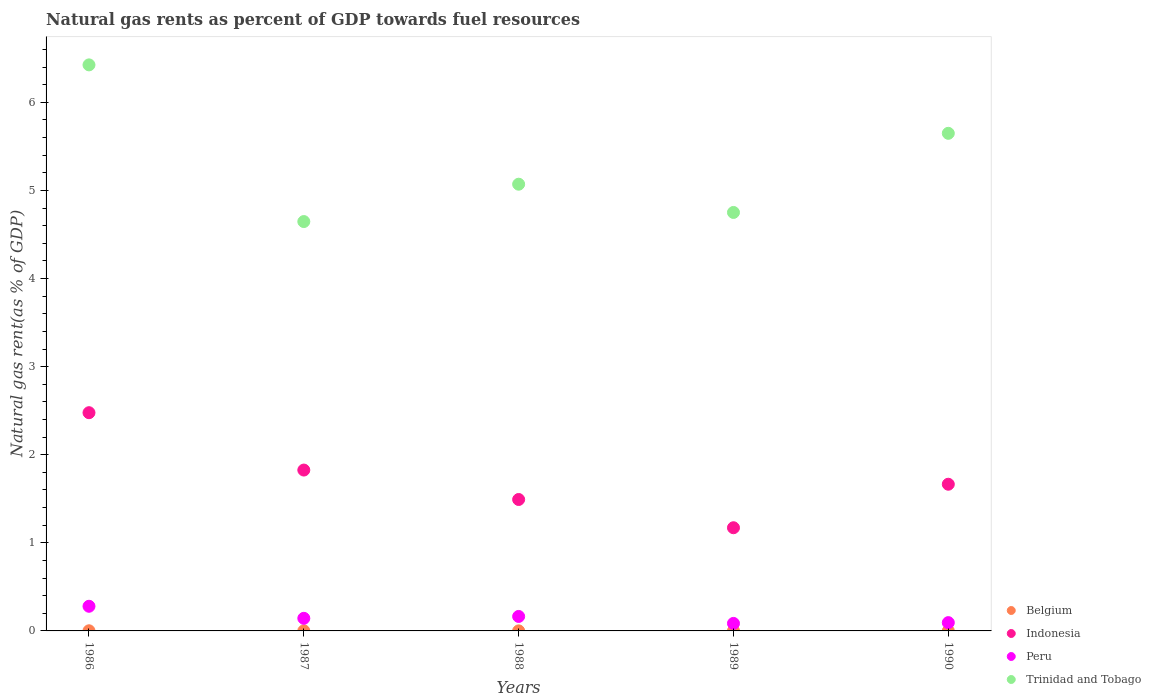What is the natural gas rent in Trinidad and Tobago in 1989?
Offer a terse response. 4.75. Across all years, what is the maximum natural gas rent in Peru?
Offer a very short reply. 0.28. Across all years, what is the minimum natural gas rent in Peru?
Provide a succinct answer. 0.09. What is the total natural gas rent in Peru in the graph?
Provide a succinct answer. 0.77. What is the difference between the natural gas rent in Belgium in 1988 and that in 1989?
Provide a short and direct response. 0. What is the difference between the natural gas rent in Peru in 1988 and the natural gas rent in Trinidad and Tobago in 1989?
Your answer should be compact. -4.59. What is the average natural gas rent in Indonesia per year?
Provide a short and direct response. 1.73. In the year 1990, what is the difference between the natural gas rent in Indonesia and natural gas rent in Peru?
Give a very brief answer. 1.57. In how many years, is the natural gas rent in Peru greater than 5.4 %?
Provide a short and direct response. 0. What is the ratio of the natural gas rent in Indonesia in 1986 to that in 1988?
Ensure brevity in your answer.  1.66. Is the natural gas rent in Belgium in 1987 less than that in 1989?
Ensure brevity in your answer.  No. Is the difference between the natural gas rent in Indonesia in 1986 and 1987 greater than the difference between the natural gas rent in Peru in 1986 and 1987?
Keep it short and to the point. Yes. What is the difference between the highest and the second highest natural gas rent in Trinidad and Tobago?
Your response must be concise. 0.78. What is the difference between the highest and the lowest natural gas rent in Trinidad and Tobago?
Offer a very short reply. 1.78. In how many years, is the natural gas rent in Belgium greater than the average natural gas rent in Belgium taken over all years?
Your answer should be very brief. 2. Is the sum of the natural gas rent in Indonesia in 1987 and 1990 greater than the maximum natural gas rent in Trinidad and Tobago across all years?
Ensure brevity in your answer.  No. Is it the case that in every year, the sum of the natural gas rent in Trinidad and Tobago and natural gas rent in Indonesia  is greater than the natural gas rent in Belgium?
Ensure brevity in your answer.  Yes. Does the natural gas rent in Belgium monotonically increase over the years?
Give a very brief answer. No. Is the natural gas rent in Belgium strictly greater than the natural gas rent in Trinidad and Tobago over the years?
Ensure brevity in your answer.  No. Is the natural gas rent in Indonesia strictly less than the natural gas rent in Peru over the years?
Your answer should be compact. No. How many dotlines are there?
Provide a short and direct response. 4. Are the values on the major ticks of Y-axis written in scientific E-notation?
Give a very brief answer. No. Does the graph contain grids?
Make the answer very short. No. How are the legend labels stacked?
Give a very brief answer. Vertical. What is the title of the graph?
Your response must be concise. Natural gas rents as percent of GDP towards fuel resources. Does "Czech Republic" appear as one of the legend labels in the graph?
Make the answer very short. No. What is the label or title of the Y-axis?
Offer a terse response. Natural gas rent(as % of GDP). What is the Natural gas rent(as % of GDP) of Belgium in 1986?
Your response must be concise. 0. What is the Natural gas rent(as % of GDP) in Indonesia in 1986?
Give a very brief answer. 2.48. What is the Natural gas rent(as % of GDP) of Peru in 1986?
Provide a succinct answer. 0.28. What is the Natural gas rent(as % of GDP) in Trinidad and Tobago in 1986?
Your response must be concise. 6.43. What is the Natural gas rent(as % of GDP) in Belgium in 1987?
Your answer should be compact. 0. What is the Natural gas rent(as % of GDP) of Indonesia in 1987?
Offer a terse response. 1.83. What is the Natural gas rent(as % of GDP) of Peru in 1987?
Your answer should be very brief. 0.14. What is the Natural gas rent(as % of GDP) of Trinidad and Tobago in 1987?
Offer a terse response. 4.65. What is the Natural gas rent(as % of GDP) in Belgium in 1988?
Ensure brevity in your answer.  0. What is the Natural gas rent(as % of GDP) of Indonesia in 1988?
Your answer should be very brief. 1.49. What is the Natural gas rent(as % of GDP) of Peru in 1988?
Offer a very short reply. 0.16. What is the Natural gas rent(as % of GDP) in Trinidad and Tobago in 1988?
Provide a short and direct response. 5.07. What is the Natural gas rent(as % of GDP) in Belgium in 1989?
Your answer should be compact. 0. What is the Natural gas rent(as % of GDP) in Indonesia in 1989?
Give a very brief answer. 1.17. What is the Natural gas rent(as % of GDP) of Peru in 1989?
Provide a short and direct response. 0.09. What is the Natural gas rent(as % of GDP) in Trinidad and Tobago in 1989?
Make the answer very short. 4.75. What is the Natural gas rent(as % of GDP) of Belgium in 1990?
Provide a succinct answer. 0. What is the Natural gas rent(as % of GDP) of Indonesia in 1990?
Offer a very short reply. 1.67. What is the Natural gas rent(as % of GDP) in Peru in 1990?
Offer a very short reply. 0.09. What is the Natural gas rent(as % of GDP) of Trinidad and Tobago in 1990?
Provide a succinct answer. 5.65. Across all years, what is the maximum Natural gas rent(as % of GDP) in Belgium?
Offer a very short reply. 0. Across all years, what is the maximum Natural gas rent(as % of GDP) in Indonesia?
Your response must be concise. 2.48. Across all years, what is the maximum Natural gas rent(as % of GDP) of Peru?
Your answer should be very brief. 0.28. Across all years, what is the maximum Natural gas rent(as % of GDP) of Trinidad and Tobago?
Your answer should be compact. 6.43. Across all years, what is the minimum Natural gas rent(as % of GDP) in Belgium?
Give a very brief answer. 0. Across all years, what is the minimum Natural gas rent(as % of GDP) in Indonesia?
Your response must be concise. 1.17. Across all years, what is the minimum Natural gas rent(as % of GDP) in Peru?
Offer a terse response. 0.09. Across all years, what is the minimum Natural gas rent(as % of GDP) in Trinidad and Tobago?
Ensure brevity in your answer.  4.65. What is the total Natural gas rent(as % of GDP) of Belgium in the graph?
Offer a terse response. 0. What is the total Natural gas rent(as % of GDP) of Indonesia in the graph?
Offer a terse response. 8.63. What is the total Natural gas rent(as % of GDP) in Peru in the graph?
Make the answer very short. 0.77. What is the total Natural gas rent(as % of GDP) of Trinidad and Tobago in the graph?
Your answer should be very brief. 26.54. What is the difference between the Natural gas rent(as % of GDP) in Belgium in 1986 and that in 1987?
Offer a very short reply. 0. What is the difference between the Natural gas rent(as % of GDP) of Indonesia in 1986 and that in 1987?
Your response must be concise. 0.65. What is the difference between the Natural gas rent(as % of GDP) in Peru in 1986 and that in 1987?
Provide a succinct answer. 0.14. What is the difference between the Natural gas rent(as % of GDP) in Trinidad and Tobago in 1986 and that in 1987?
Offer a terse response. 1.78. What is the difference between the Natural gas rent(as % of GDP) in Belgium in 1986 and that in 1988?
Provide a succinct answer. 0. What is the difference between the Natural gas rent(as % of GDP) of Indonesia in 1986 and that in 1988?
Provide a succinct answer. 0.99. What is the difference between the Natural gas rent(as % of GDP) in Peru in 1986 and that in 1988?
Your answer should be very brief. 0.12. What is the difference between the Natural gas rent(as % of GDP) of Trinidad and Tobago in 1986 and that in 1988?
Provide a succinct answer. 1.35. What is the difference between the Natural gas rent(as % of GDP) of Belgium in 1986 and that in 1989?
Provide a short and direct response. 0. What is the difference between the Natural gas rent(as % of GDP) of Indonesia in 1986 and that in 1989?
Keep it short and to the point. 1.31. What is the difference between the Natural gas rent(as % of GDP) of Peru in 1986 and that in 1989?
Offer a very short reply. 0.19. What is the difference between the Natural gas rent(as % of GDP) in Trinidad and Tobago in 1986 and that in 1989?
Your answer should be very brief. 1.68. What is the difference between the Natural gas rent(as % of GDP) of Belgium in 1986 and that in 1990?
Make the answer very short. 0. What is the difference between the Natural gas rent(as % of GDP) of Indonesia in 1986 and that in 1990?
Provide a succinct answer. 0.81. What is the difference between the Natural gas rent(as % of GDP) of Peru in 1986 and that in 1990?
Ensure brevity in your answer.  0.19. What is the difference between the Natural gas rent(as % of GDP) in Trinidad and Tobago in 1986 and that in 1990?
Ensure brevity in your answer.  0.78. What is the difference between the Natural gas rent(as % of GDP) of Belgium in 1987 and that in 1988?
Make the answer very short. 0. What is the difference between the Natural gas rent(as % of GDP) in Indonesia in 1987 and that in 1988?
Keep it short and to the point. 0.33. What is the difference between the Natural gas rent(as % of GDP) of Peru in 1987 and that in 1988?
Provide a short and direct response. -0.02. What is the difference between the Natural gas rent(as % of GDP) of Trinidad and Tobago in 1987 and that in 1988?
Your answer should be very brief. -0.42. What is the difference between the Natural gas rent(as % of GDP) of Belgium in 1987 and that in 1989?
Keep it short and to the point. 0. What is the difference between the Natural gas rent(as % of GDP) of Indonesia in 1987 and that in 1989?
Give a very brief answer. 0.65. What is the difference between the Natural gas rent(as % of GDP) of Peru in 1987 and that in 1989?
Offer a terse response. 0.06. What is the difference between the Natural gas rent(as % of GDP) in Trinidad and Tobago in 1987 and that in 1989?
Your answer should be compact. -0.1. What is the difference between the Natural gas rent(as % of GDP) of Belgium in 1987 and that in 1990?
Give a very brief answer. 0. What is the difference between the Natural gas rent(as % of GDP) of Indonesia in 1987 and that in 1990?
Offer a terse response. 0.16. What is the difference between the Natural gas rent(as % of GDP) in Peru in 1987 and that in 1990?
Give a very brief answer. 0.05. What is the difference between the Natural gas rent(as % of GDP) in Trinidad and Tobago in 1987 and that in 1990?
Make the answer very short. -1. What is the difference between the Natural gas rent(as % of GDP) in Belgium in 1988 and that in 1989?
Your response must be concise. 0. What is the difference between the Natural gas rent(as % of GDP) in Indonesia in 1988 and that in 1989?
Give a very brief answer. 0.32. What is the difference between the Natural gas rent(as % of GDP) of Peru in 1988 and that in 1989?
Keep it short and to the point. 0.08. What is the difference between the Natural gas rent(as % of GDP) of Trinidad and Tobago in 1988 and that in 1989?
Offer a very short reply. 0.32. What is the difference between the Natural gas rent(as % of GDP) of Belgium in 1988 and that in 1990?
Make the answer very short. 0. What is the difference between the Natural gas rent(as % of GDP) of Indonesia in 1988 and that in 1990?
Your answer should be very brief. -0.17. What is the difference between the Natural gas rent(as % of GDP) of Peru in 1988 and that in 1990?
Your response must be concise. 0.07. What is the difference between the Natural gas rent(as % of GDP) in Trinidad and Tobago in 1988 and that in 1990?
Provide a short and direct response. -0.58. What is the difference between the Natural gas rent(as % of GDP) in Indonesia in 1989 and that in 1990?
Make the answer very short. -0.49. What is the difference between the Natural gas rent(as % of GDP) of Peru in 1989 and that in 1990?
Provide a succinct answer. -0.01. What is the difference between the Natural gas rent(as % of GDP) in Trinidad and Tobago in 1989 and that in 1990?
Make the answer very short. -0.9. What is the difference between the Natural gas rent(as % of GDP) in Belgium in 1986 and the Natural gas rent(as % of GDP) in Indonesia in 1987?
Provide a short and direct response. -1.82. What is the difference between the Natural gas rent(as % of GDP) of Belgium in 1986 and the Natural gas rent(as % of GDP) of Peru in 1987?
Your answer should be compact. -0.14. What is the difference between the Natural gas rent(as % of GDP) in Belgium in 1986 and the Natural gas rent(as % of GDP) in Trinidad and Tobago in 1987?
Your response must be concise. -4.64. What is the difference between the Natural gas rent(as % of GDP) in Indonesia in 1986 and the Natural gas rent(as % of GDP) in Peru in 1987?
Make the answer very short. 2.33. What is the difference between the Natural gas rent(as % of GDP) in Indonesia in 1986 and the Natural gas rent(as % of GDP) in Trinidad and Tobago in 1987?
Your answer should be compact. -2.17. What is the difference between the Natural gas rent(as % of GDP) in Peru in 1986 and the Natural gas rent(as % of GDP) in Trinidad and Tobago in 1987?
Offer a very short reply. -4.37. What is the difference between the Natural gas rent(as % of GDP) of Belgium in 1986 and the Natural gas rent(as % of GDP) of Indonesia in 1988?
Keep it short and to the point. -1.49. What is the difference between the Natural gas rent(as % of GDP) in Belgium in 1986 and the Natural gas rent(as % of GDP) in Peru in 1988?
Ensure brevity in your answer.  -0.16. What is the difference between the Natural gas rent(as % of GDP) of Belgium in 1986 and the Natural gas rent(as % of GDP) of Trinidad and Tobago in 1988?
Offer a terse response. -5.07. What is the difference between the Natural gas rent(as % of GDP) of Indonesia in 1986 and the Natural gas rent(as % of GDP) of Peru in 1988?
Give a very brief answer. 2.31. What is the difference between the Natural gas rent(as % of GDP) in Indonesia in 1986 and the Natural gas rent(as % of GDP) in Trinidad and Tobago in 1988?
Provide a succinct answer. -2.59. What is the difference between the Natural gas rent(as % of GDP) of Peru in 1986 and the Natural gas rent(as % of GDP) of Trinidad and Tobago in 1988?
Keep it short and to the point. -4.79. What is the difference between the Natural gas rent(as % of GDP) of Belgium in 1986 and the Natural gas rent(as % of GDP) of Indonesia in 1989?
Your response must be concise. -1.17. What is the difference between the Natural gas rent(as % of GDP) in Belgium in 1986 and the Natural gas rent(as % of GDP) in Peru in 1989?
Offer a terse response. -0.08. What is the difference between the Natural gas rent(as % of GDP) of Belgium in 1986 and the Natural gas rent(as % of GDP) of Trinidad and Tobago in 1989?
Your response must be concise. -4.75. What is the difference between the Natural gas rent(as % of GDP) in Indonesia in 1986 and the Natural gas rent(as % of GDP) in Peru in 1989?
Your answer should be compact. 2.39. What is the difference between the Natural gas rent(as % of GDP) in Indonesia in 1986 and the Natural gas rent(as % of GDP) in Trinidad and Tobago in 1989?
Provide a short and direct response. -2.27. What is the difference between the Natural gas rent(as % of GDP) of Peru in 1986 and the Natural gas rent(as % of GDP) of Trinidad and Tobago in 1989?
Your response must be concise. -4.47. What is the difference between the Natural gas rent(as % of GDP) in Belgium in 1986 and the Natural gas rent(as % of GDP) in Indonesia in 1990?
Provide a succinct answer. -1.66. What is the difference between the Natural gas rent(as % of GDP) in Belgium in 1986 and the Natural gas rent(as % of GDP) in Peru in 1990?
Provide a short and direct response. -0.09. What is the difference between the Natural gas rent(as % of GDP) in Belgium in 1986 and the Natural gas rent(as % of GDP) in Trinidad and Tobago in 1990?
Give a very brief answer. -5.65. What is the difference between the Natural gas rent(as % of GDP) in Indonesia in 1986 and the Natural gas rent(as % of GDP) in Peru in 1990?
Keep it short and to the point. 2.38. What is the difference between the Natural gas rent(as % of GDP) in Indonesia in 1986 and the Natural gas rent(as % of GDP) in Trinidad and Tobago in 1990?
Your answer should be very brief. -3.17. What is the difference between the Natural gas rent(as % of GDP) in Peru in 1986 and the Natural gas rent(as % of GDP) in Trinidad and Tobago in 1990?
Provide a short and direct response. -5.37. What is the difference between the Natural gas rent(as % of GDP) of Belgium in 1987 and the Natural gas rent(as % of GDP) of Indonesia in 1988?
Provide a succinct answer. -1.49. What is the difference between the Natural gas rent(as % of GDP) in Belgium in 1987 and the Natural gas rent(as % of GDP) in Peru in 1988?
Your response must be concise. -0.16. What is the difference between the Natural gas rent(as % of GDP) of Belgium in 1987 and the Natural gas rent(as % of GDP) of Trinidad and Tobago in 1988?
Provide a succinct answer. -5.07. What is the difference between the Natural gas rent(as % of GDP) of Indonesia in 1987 and the Natural gas rent(as % of GDP) of Peru in 1988?
Make the answer very short. 1.66. What is the difference between the Natural gas rent(as % of GDP) of Indonesia in 1987 and the Natural gas rent(as % of GDP) of Trinidad and Tobago in 1988?
Give a very brief answer. -3.24. What is the difference between the Natural gas rent(as % of GDP) of Peru in 1987 and the Natural gas rent(as % of GDP) of Trinidad and Tobago in 1988?
Provide a succinct answer. -4.93. What is the difference between the Natural gas rent(as % of GDP) in Belgium in 1987 and the Natural gas rent(as % of GDP) in Indonesia in 1989?
Offer a terse response. -1.17. What is the difference between the Natural gas rent(as % of GDP) of Belgium in 1987 and the Natural gas rent(as % of GDP) of Peru in 1989?
Make the answer very short. -0.08. What is the difference between the Natural gas rent(as % of GDP) in Belgium in 1987 and the Natural gas rent(as % of GDP) in Trinidad and Tobago in 1989?
Your answer should be very brief. -4.75. What is the difference between the Natural gas rent(as % of GDP) of Indonesia in 1987 and the Natural gas rent(as % of GDP) of Peru in 1989?
Provide a short and direct response. 1.74. What is the difference between the Natural gas rent(as % of GDP) of Indonesia in 1987 and the Natural gas rent(as % of GDP) of Trinidad and Tobago in 1989?
Keep it short and to the point. -2.92. What is the difference between the Natural gas rent(as % of GDP) in Peru in 1987 and the Natural gas rent(as % of GDP) in Trinidad and Tobago in 1989?
Offer a terse response. -4.61. What is the difference between the Natural gas rent(as % of GDP) of Belgium in 1987 and the Natural gas rent(as % of GDP) of Indonesia in 1990?
Give a very brief answer. -1.66. What is the difference between the Natural gas rent(as % of GDP) in Belgium in 1987 and the Natural gas rent(as % of GDP) in Peru in 1990?
Your answer should be very brief. -0.09. What is the difference between the Natural gas rent(as % of GDP) in Belgium in 1987 and the Natural gas rent(as % of GDP) in Trinidad and Tobago in 1990?
Make the answer very short. -5.65. What is the difference between the Natural gas rent(as % of GDP) of Indonesia in 1987 and the Natural gas rent(as % of GDP) of Peru in 1990?
Your response must be concise. 1.73. What is the difference between the Natural gas rent(as % of GDP) of Indonesia in 1987 and the Natural gas rent(as % of GDP) of Trinidad and Tobago in 1990?
Offer a terse response. -3.82. What is the difference between the Natural gas rent(as % of GDP) in Peru in 1987 and the Natural gas rent(as % of GDP) in Trinidad and Tobago in 1990?
Make the answer very short. -5.51. What is the difference between the Natural gas rent(as % of GDP) in Belgium in 1988 and the Natural gas rent(as % of GDP) in Indonesia in 1989?
Keep it short and to the point. -1.17. What is the difference between the Natural gas rent(as % of GDP) of Belgium in 1988 and the Natural gas rent(as % of GDP) of Peru in 1989?
Keep it short and to the point. -0.08. What is the difference between the Natural gas rent(as % of GDP) of Belgium in 1988 and the Natural gas rent(as % of GDP) of Trinidad and Tobago in 1989?
Provide a short and direct response. -4.75. What is the difference between the Natural gas rent(as % of GDP) of Indonesia in 1988 and the Natural gas rent(as % of GDP) of Peru in 1989?
Keep it short and to the point. 1.41. What is the difference between the Natural gas rent(as % of GDP) of Indonesia in 1988 and the Natural gas rent(as % of GDP) of Trinidad and Tobago in 1989?
Your response must be concise. -3.26. What is the difference between the Natural gas rent(as % of GDP) of Peru in 1988 and the Natural gas rent(as % of GDP) of Trinidad and Tobago in 1989?
Provide a succinct answer. -4.59. What is the difference between the Natural gas rent(as % of GDP) of Belgium in 1988 and the Natural gas rent(as % of GDP) of Indonesia in 1990?
Give a very brief answer. -1.66. What is the difference between the Natural gas rent(as % of GDP) of Belgium in 1988 and the Natural gas rent(as % of GDP) of Peru in 1990?
Your answer should be compact. -0.09. What is the difference between the Natural gas rent(as % of GDP) of Belgium in 1988 and the Natural gas rent(as % of GDP) of Trinidad and Tobago in 1990?
Your response must be concise. -5.65. What is the difference between the Natural gas rent(as % of GDP) of Indonesia in 1988 and the Natural gas rent(as % of GDP) of Peru in 1990?
Ensure brevity in your answer.  1.4. What is the difference between the Natural gas rent(as % of GDP) in Indonesia in 1988 and the Natural gas rent(as % of GDP) in Trinidad and Tobago in 1990?
Ensure brevity in your answer.  -4.16. What is the difference between the Natural gas rent(as % of GDP) in Peru in 1988 and the Natural gas rent(as % of GDP) in Trinidad and Tobago in 1990?
Give a very brief answer. -5.48. What is the difference between the Natural gas rent(as % of GDP) of Belgium in 1989 and the Natural gas rent(as % of GDP) of Indonesia in 1990?
Make the answer very short. -1.66. What is the difference between the Natural gas rent(as % of GDP) in Belgium in 1989 and the Natural gas rent(as % of GDP) in Peru in 1990?
Keep it short and to the point. -0.09. What is the difference between the Natural gas rent(as % of GDP) of Belgium in 1989 and the Natural gas rent(as % of GDP) of Trinidad and Tobago in 1990?
Give a very brief answer. -5.65. What is the difference between the Natural gas rent(as % of GDP) of Indonesia in 1989 and the Natural gas rent(as % of GDP) of Peru in 1990?
Provide a short and direct response. 1.08. What is the difference between the Natural gas rent(as % of GDP) in Indonesia in 1989 and the Natural gas rent(as % of GDP) in Trinidad and Tobago in 1990?
Your answer should be very brief. -4.48. What is the difference between the Natural gas rent(as % of GDP) of Peru in 1989 and the Natural gas rent(as % of GDP) of Trinidad and Tobago in 1990?
Give a very brief answer. -5.56. What is the average Natural gas rent(as % of GDP) of Belgium per year?
Offer a terse response. 0. What is the average Natural gas rent(as % of GDP) in Indonesia per year?
Offer a terse response. 1.73. What is the average Natural gas rent(as % of GDP) of Peru per year?
Give a very brief answer. 0.15. What is the average Natural gas rent(as % of GDP) in Trinidad and Tobago per year?
Your answer should be very brief. 5.31. In the year 1986, what is the difference between the Natural gas rent(as % of GDP) in Belgium and Natural gas rent(as % of GDP) in Indonesia?
Give a very brief answer. -2.48. In the year 1986, what is the difference between the Natural gas rent(as % of GDP) in Belgium and Natural gas rent(as % of GDP) in Peru?
Offer a terse response. -0.28. In the year 1986, what is the difference between the Natural gas rent(as % of GDP) of Belgium and Natural gas rent(as % of GDP) of Trinidad and Tobago?
Provide a succinct answer. -6.42. In the year 1986, what is the difference between the Natural gas rent(as % of GDP) of Indonesia and Natural gas rent(as % of GDP) of Peru?
Give a very brief answer. 2.2. In the year 1986, what is the difference between the Natural gas rent(as % of GDP) of Indonesia and Natural gas rent(as % of GDP) of Trinidad and Tobago?
Make the answer very short. -3.95. In the year 1986, what is the difference between the Natural gas rent(as % of GDP) of Peru and Natural gas rent(as % of GDP) of Trinidad and Tobago?
Give a very brief answer. -6.15. In the year 1987, what is the difference between the Natural gas rent(as % of GDP) in Belgium and Natural gas rent(as % of GDP) in Indonesia?
Give a very brief answer. -1.82. In the year 1987, what is the difference between the Natural gas rent(as % of GDP) in Belgium and Natural gas rent(as % of GDP) in Peru?
Provide a succinct answer. -0.14. In the year 1987, what is the difference between the Natural gas rent(as % of GDP) in Belgium and Natural gas rent(as % of GDP) in Trinidad and Tobago?
Give a very brief answer. -4.65. In the year 1987, what is the difference between the Natural gas rent(as % of GDP) in Indonesia and Natural gas rent(as % of GDP) in Peru?
Your response must be concise. 1.68. In the year 1987, what is the difference between the Natural gas rent(as % of GDP) in Indonesia and Natural gas rent(as % of GDP) in Trinidad and Tobago?
Your answer should be very brief. -2.82. In the year 1987, what is the difference between the Natural gas rent(as % of GDP) of Peru and Natural gas rent(as % of GDP) of Trinidad and Tobago?
Provide a succinct answer. -4.5. In the year 1988, what is the difference between the Natural gas rent(as % of GDP) of Belgium and Natural gas rent(as % of GDP) of Indonesia?
Make the answer very short. -1.49. In the year 1988, what is the difference between the Natural gas rent(as % of GDP) in Belgium and Natural gas rent(as % of GDP) in Peru?
Provide a succinct answer. -0.16. In the year 1988, what is the difference between the Natural gas rent(as % of GDP) of Belgium and Natural gas rent(as % of GDP) of Trinidad and Tobago?
Offer a very short reply. -5.07. In the year 1988, what is the difference between the Natural gas rent(as % of GDP) of Indonesia and Natural gas rent(as % of GDP) of Peru?
Give a very brief answer. 1.33. In the year 1988, what is the difference between the Natural gas rent(as % of GDP) of Indonesia and Natural gas rent(as % of GDP) of Trinidad and Tobago?
Your response must be concise. -3.58. In the year 1988, what is the difference between the Natural gas rent(as % of GDP) of Peru and Natural gas rent(as % of GDP) of Trinidad and Tobago?
Provide a short and direct response. -4.91. In the year 1989, what is the difference between the Natural gas rent(as % of GDP) in Belgium and Natural gas rent(as % of GDP) in Indonesia?
Provide a succinct answer. -1.17. In the year 1989, what is the difference between the Natural gas rent(as % of GDP) of Belgium and Natural gas rent(as % of GDP) of Peru?
Your answer should be compact. -0.09. In the year 1989, what is the difference between the Natural gas rent(as % of GDP) of Belgium and Natural gas rent(as % of GDP) of Trinidad and Tobago?
Keep it short and to the point. -4.75. In the year 1989, what is the difference between the Natural gas rent(as % of GDP) of Indonesia and Natural gas rent(as % of GDP) of Peru?
Your answer should be compact. 1.09. In the year 1989, what is the difference between the Natural gas rent(as % of GDP) in Indonesia and Natural gas rent(as % of GDP) in Trinidad and Tobago?
Your response must be concise. -3.58. In the year 1989, what is the difference between the Natural gas rent(as % of GDP) of Peru and Natural gas rent(as % of GDP) of Trinidad and Tobago?
Keep it short and to the point. -4.66. In the year 1990, what is the difference between the Natural gas rent(as % of GDP) of Belgium and Natural gas rent(as % of GDP) of Indonesia?
Your response must be concise. -1.66. In the year 1990, what is the difference between the Natural gas rent(as % of GDP) of Belgium and Natural gas rent(as % of GDP) of Peru?
Your answer should be very brief. -0.09. In the year 1990, what is the difference between the Natural gas rent(as % of GDP) of Belgium and Natural gas rent(as % of GDP) of Trinidad and Tobago?
Ensure brevity in your answer.  -5.65. In the year 1990, what is the difference between the Natural gas rent(as % of GDP) of Indonesia and Natural gas rent(as % of GDP) of Peru?
Offer a terse response. 1.57. In the year 1990, what is the difference between the Natural gas rent(as % of GDP) in Indonesia and Natural gas rent(as % of GDP) in Trinidad and Tobago?
Make the answer very short. -3.98. In the year 1990, what is the difference between the Natural gas rent(as % of GDP) in Peru and Natural gas rent(as % of GDP) in Trinidad and Tobago?
Keep it short and to the point. -5.55. What is the ratio of the Natural gas rent(as % of GDP) in Belgium in 1986 to that in 1987?
Provide a short and direct response. 1.7. What is the ratio of the Natural gas rent(as % of GDP) of Indonesia in 1986 to that in 1987?
Your answer should be very brief. 1.36. What is the ratio of the Natural gas rent(as % of GDP) of Peru in 1986 to that in 1987?
Make the answer very short. 1.96. What is the ratio of the Natural gas rent(as % of GDP) of Trinidad and Tobago in 1986 to that in 1987?
Your answer should be very brief. 1.38. What is the ratio of the Natural gas rent(as % of GDP) of Belgium in 1986 to that in 1988?
Keep it short and to the point. 3.39. What is the ratio of the Natural gas rent(as % of GDP) of Indonesia in 1986 to that in 1988?
Offer a terse response. 1.66. What is the ratio of the Natural gas rent(as % of GDP) in Peru in 1986 to that in 1988?
Your answer should be compact. 1.7. What is the ratio of the Natural gas rent(as % of GDP) in Trinidad and Tobago in 1986 to that in 1988?
Give a very brief answer. 1.27. What is the ratio of the Natural gas rent(as % of GDP) in Belgium in 1986 to that in 1989?
Ensure brevity in your answer.  4.91. What is the ratio of the Natural gas rent(as % of GDP) of Indonesia in 1986 to that in 1989?
Your answer should be very brief. 2.12. What is the ratio of the Natural gas rent(as % of GDP) of Peru in 1986 to that in 1989?
Offer a terse response. 3.28. What is the ratio of the Natural gas rent(as % of GDP) of Trinidad and Tobago in 1986 to that in 1989?
Your response must be concise. 1.35. What is the ratio of the Natural gas rent(as % of GDP) in Belgium in 1986 to that in 1990?
Make the answer very short. 5.2. What is the ratio of the Natural gas rent(as % of GDP) of Indonesia in 1986 to that in 1990?
Offer a terse response. 1.49. What is the ratio of the Natural gas rent(as % of GDP) in Peru in 1986 to that in 1990?
Your answer should be compact. 2.97. What is the ratio of the Natural gas rent(as % of GDP) of Trinidad and Tobago in 1986 to that in 1990?
Your answer should be very brief. 1.14. What is the ratio of the Natural gas rent(as % of GDP) of Belgium in 1987 to that in 1988?
Your answer should be very brief. 2. What is the ratio of the Natural gas rent(as % of GDP) in Indonesia in 1987 to that in 1988?
Keep it short and to the point. 1.22. What is the ratio of the Natural gas rent(as % of GDP) of Peru in 1987 to that in 1988?
Give a very brief answer. 0.87. What is the ratio of the Natural gas rent(as % of GDP) in Trinidad and Tobago in 1987 to that in 1988?
Provide a short and direct response. 0.92. What is the ratio of the Natural gas rent(as % of GDP) in Belgium in 1987 to that in 1989?
Offer a very short reply. 2.89. What is the ratio of the Natural gas rent(as % of GDP) in Indonesia in 1987 to that in 1989?
Your response must be concise. 1.56. What is the ratio of the Natural gas rent(as % of GDP) in Peru in 1987 to that in 1989?
Keep it short and to the point. 1.68. What is the ratio of the Natural gas rent(as % of GDP) in Trinidad and Tobago in 1987 to that in 1989?
Your response must be concise. 0.98. What is the ratio of the Natural gas rent(as % of GDP) of Belgium in 1987 to that in 1990?
Provide a short and direct response. 3.07. What is the ratio of the Natural gas rent(as % of GDP) in Indonesia in 1987 to that in 1990?
Offer a very short reply. 1.1. What is the ratio of the Natural gas rent(as % of GDP) in Peru in 1987 to that in 1990?
Your answer should be compact. 1.52. What is the ratio of the Natural gas rent(as % of GDP) in Trinidad and Tobago in 1987 to that in 1990?
Offer a very short reply. 0.82. What is the ratio of the Natural gas rent(as % of GDP) of Belgium in 1988 to that in 1989?
Offer a terse response. 1.45. What is the ratio of the Natural gas rent(as % of GDP) of Indonesia in 1988 to that in 1989?
Ensure brevity in your answer.  1.27. What is the ratio of the Natural gas rent(as % of GDP) in Peru in 1988 to that in 1989?
Give a very brief answer. 1.93. What is the ratio of the Natural gas rent(as % of GDP) of Trinidad and Tobago in 1988 to that in 1989?
Your answer should be very brief. 1.07. What is the ratio of the Natural gas rent(as % of GDP) of Belgium in 1988 to that in 1990?
Offer a very short reply. 1.53. What is the ratio of the Natural gas rent(as % of GDP) in Indonesia in 1988 to that in 1990?
Give a very brief answer. 0.9. What is the ratio of the Natural gas rent(as % of GDP) of Peru in 1988 to that in 1990?
Your response must be concise. 1.75. What is the ratio of the Natural gas rent(as % of GDP) in Trinidad and Tobago in 1988 to that in 1990?
Your response must be concise. 0.9. What is the ratio of the Natural gas rent(as % of GDP) in Belgium in 1989 to that in 1990?
Make the answer very short. 1.06. What is the ratio of the Natural gas rent(as % of GDP) of Indonesia in 1989 to that in 1990?
Give a very brief answer. 0.7. What is the ratio of the Natural gas rent(as % of GDP) in Peru in 1989 to that in 1990?
Keep it short and to the point. 0.91. What is the ratio of the Natural gas rent(as % of GDP) in Trinidad and Tobago in 1989 to that in 1990?
Provide a succinct answer. 0.84. What is the difference between the highest and the second highest Natural gas rent(as % of GDP) of Belgium?
Offer a very short reply. 0. What is the difference between the highest and the second highest Natural gas rent(as % of GDP) of Indonesia?
Keep it short and to the point. 0.65. What is the difference between the highest and the second highest Natural gas rent(as % of GDP) in Peru?
Ensure brevity in your answer.  0.12. What is the difference between the highest and the second highest Natural gas rent(as % of GDP) in Trinidad and Tobago?
Provide a succinct answer. 0.78. What is the difference between the highest and the lowest Natural gas rent(as % of GDP) in Belgium?
Make the answer very short. 0. What is the difference between the highest and the lowest Natural gas rent(as % of GDP) in Indonesia?
Provide a succinct answer. 1.31. What is the difference between the highest and the lowest Natural gas rent(as % of GDP) in Peru?
Keep it short and to the point. 0.19. What is the difference between the highest and the lowest Natural gas rent(as % of GDP) of Trinidad and Tobago?
Your response must be concise. 1.78. 